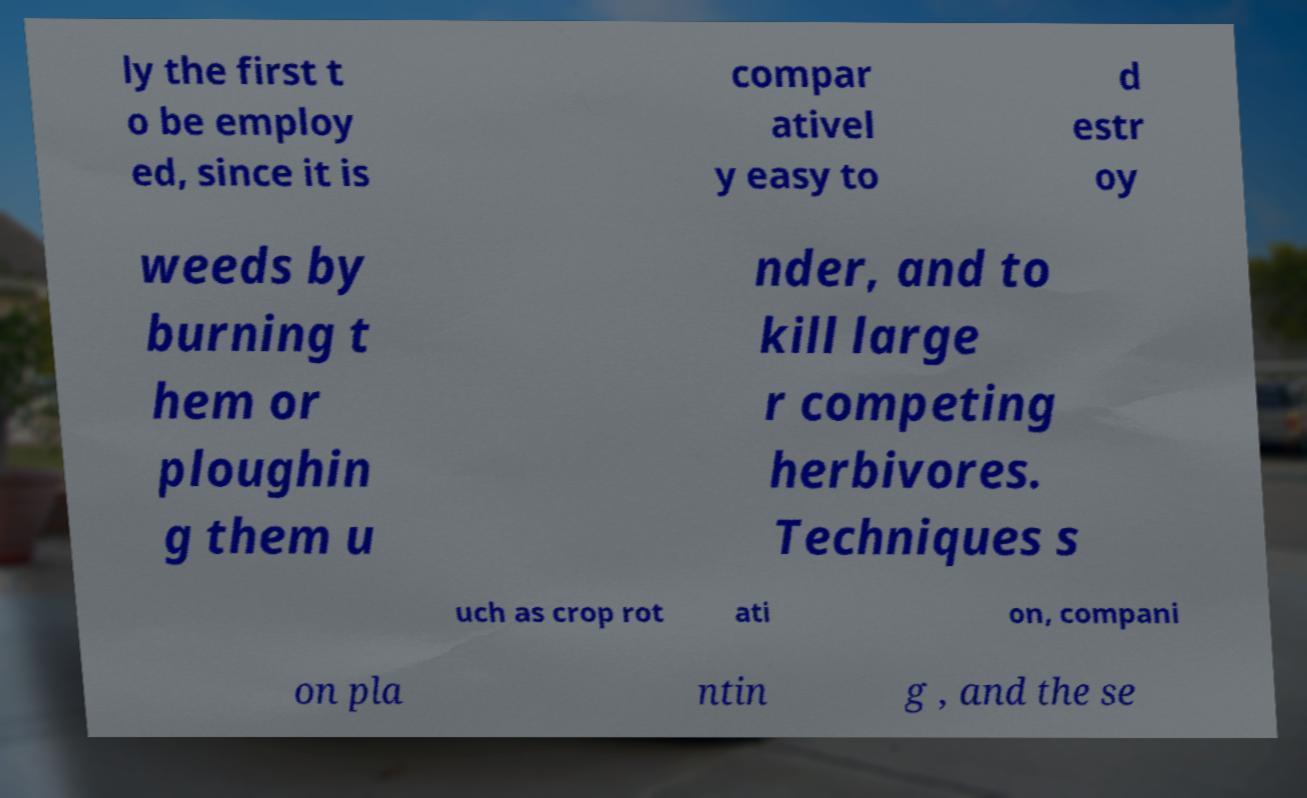Could you extract and type out the text from this image? ly the first t o be employ ed, since it is compar ativel y easy to d estr oy weeds by burning t hem or ploughin g them u nder, and to kill large r competing herbivores. Techniques s uch as crop rot ati on, compani on pla ntin g , and the se 